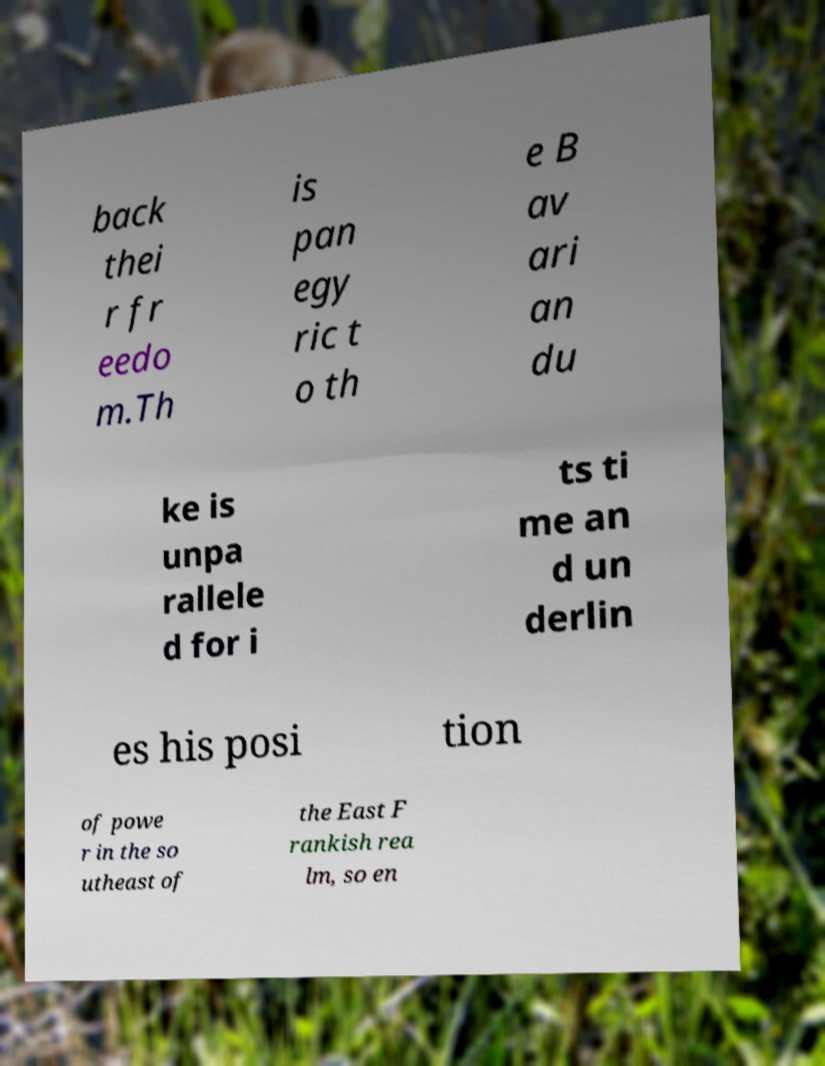Can you accurately transcribe the text from the provided image for me? back thei r fr eedo m.Th is pan egy ric t o th e B av ari an du ke is unpa rallele d for i ts ti me an d un derlin es his posi tion of powe r in the so utheast of the East F rankish rea lm, so en 